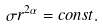<formula> <loc_0><loc_0><loc_500><loc_500>\sigma r ^ { 2 \alpha } = c o n s t .</formula> 